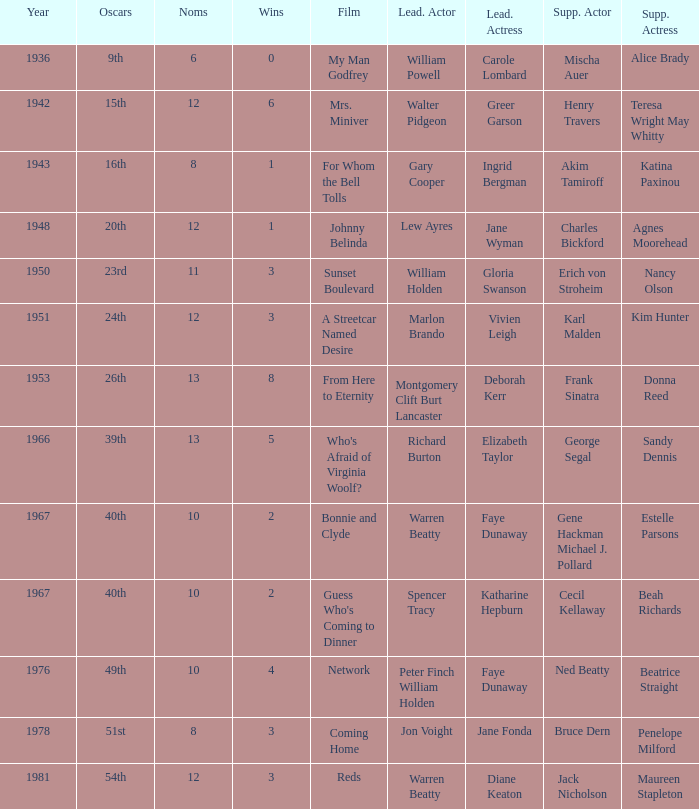Who was the supporting actress in 1943? Katina Paxinou. 